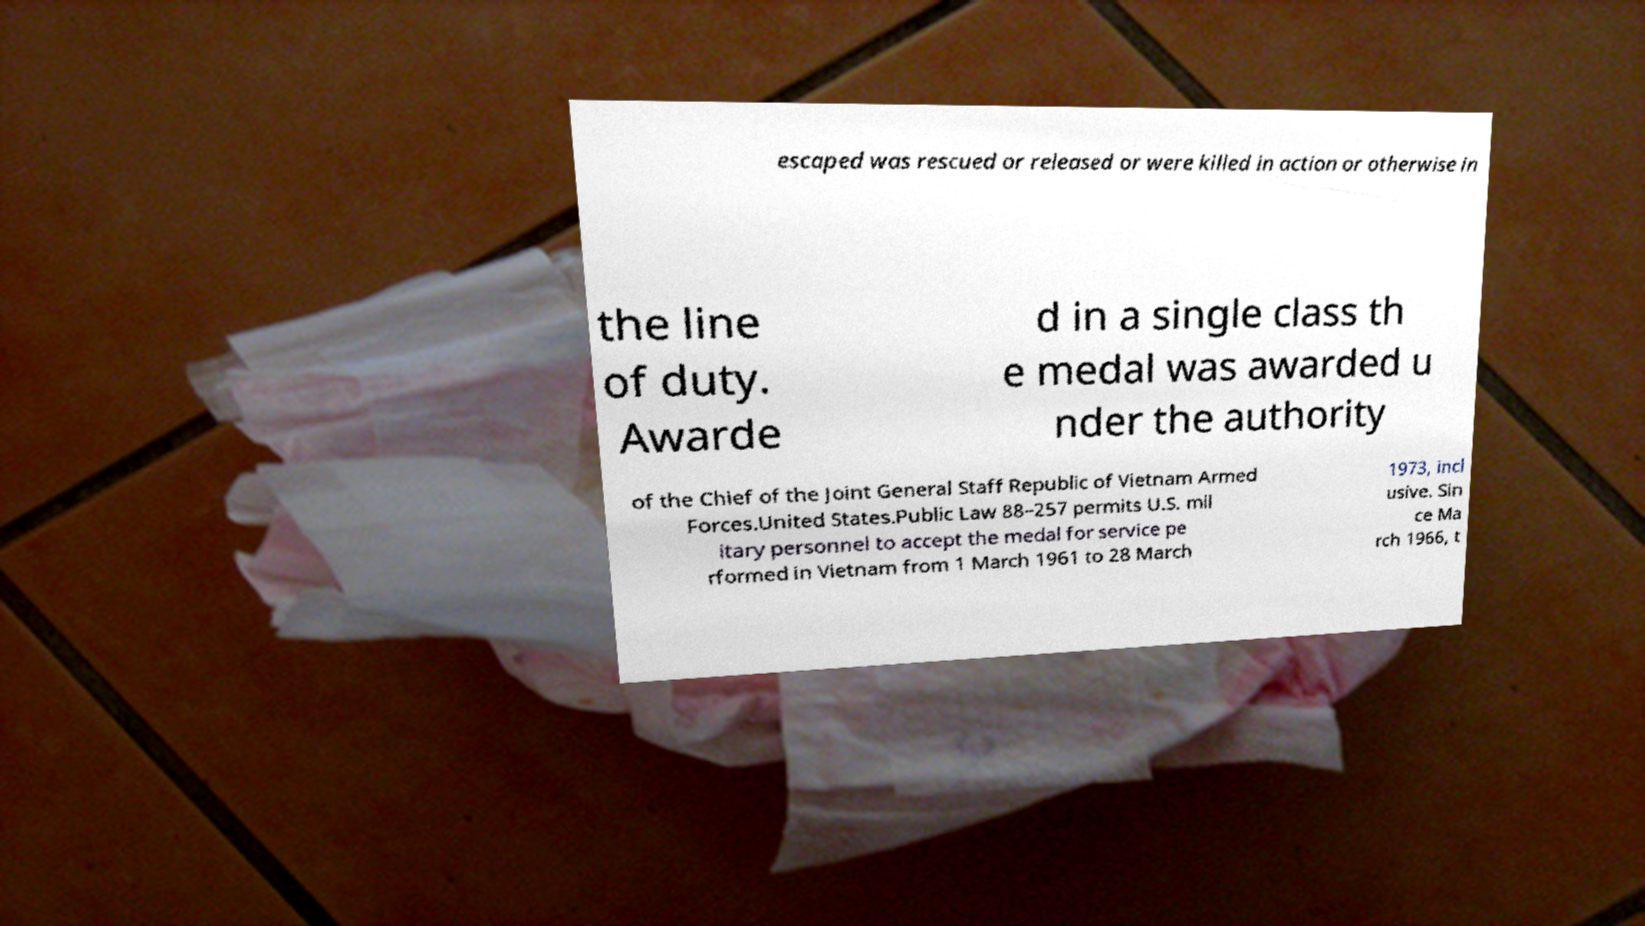What messages or text are displayed in this image? I need them in a readable, typed format. escaped was rescued or released or were killed in action or otherwise in the line of duty. Awarde d in a single class th e medal was awarded u nder the authority of the Chief of the Joint General Staff Republic of Vietnam Armed Forces.United States.Public Law 88–257 permits U.S. mil itary personnel to accept the medal for service pe rformed in Vietnam from 1 March 1961 to 28 March 1973, incl usive. Sin ce Ma rch 1966, t 